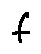<formula> <loc_0><loc_0><loc_500><loc_500>f</formula> 